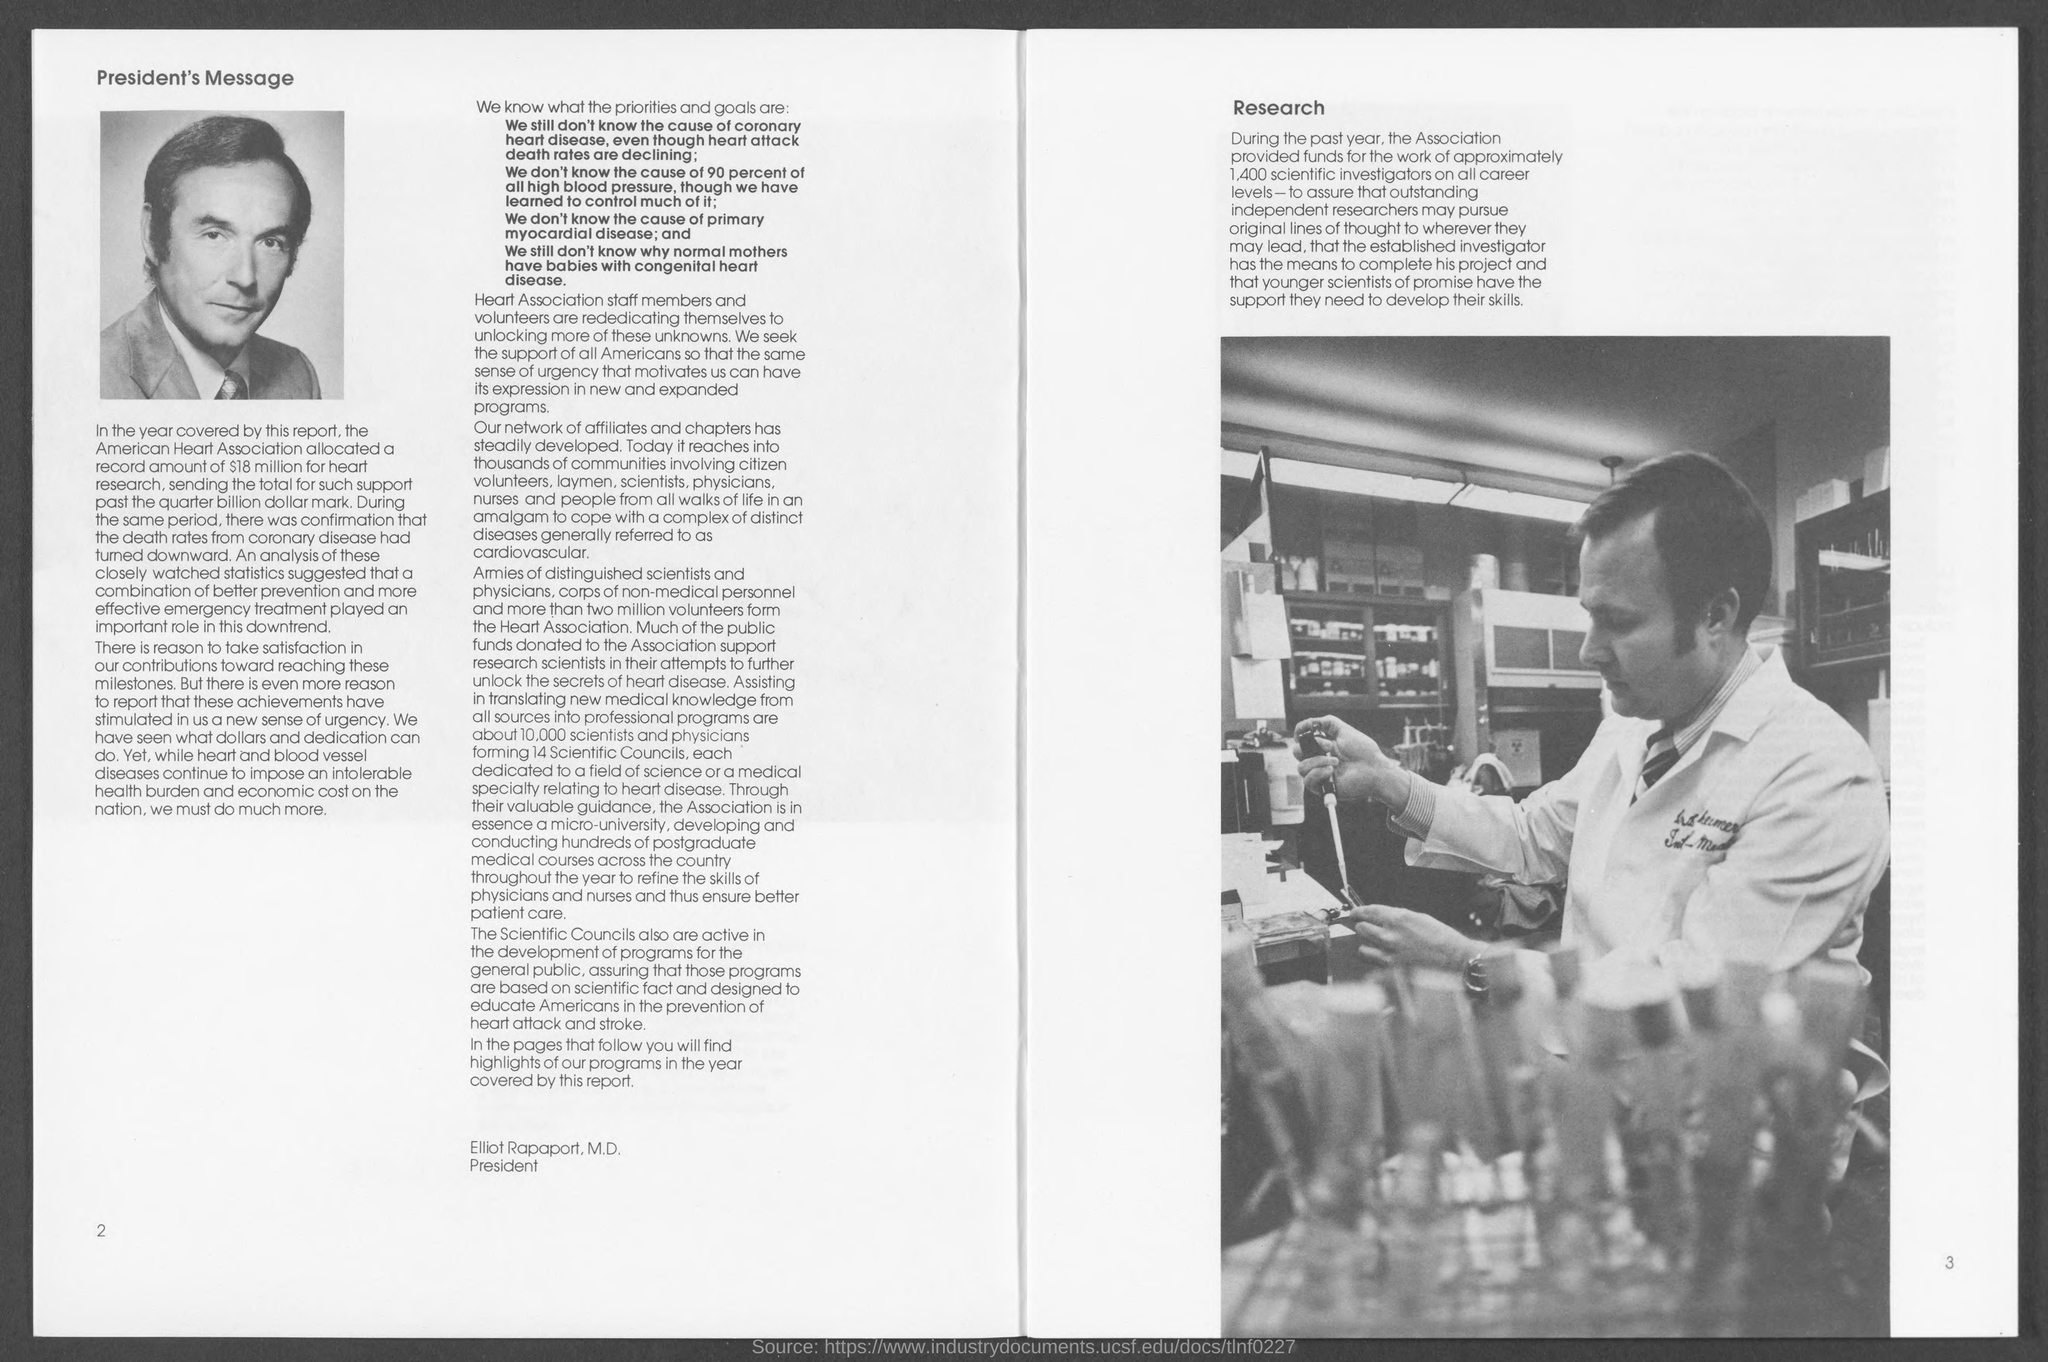Give some essential details in this illustration. The association provided funding for 1,400 scientific investigators. As stated in the document, 14 Scientific Councils were formed. Heart and blood vessel diseases continue to impose an intolerable health and economic burden on our nation. The top left corner of the first page contains the president's message. Elliot Rapaport is the president. 